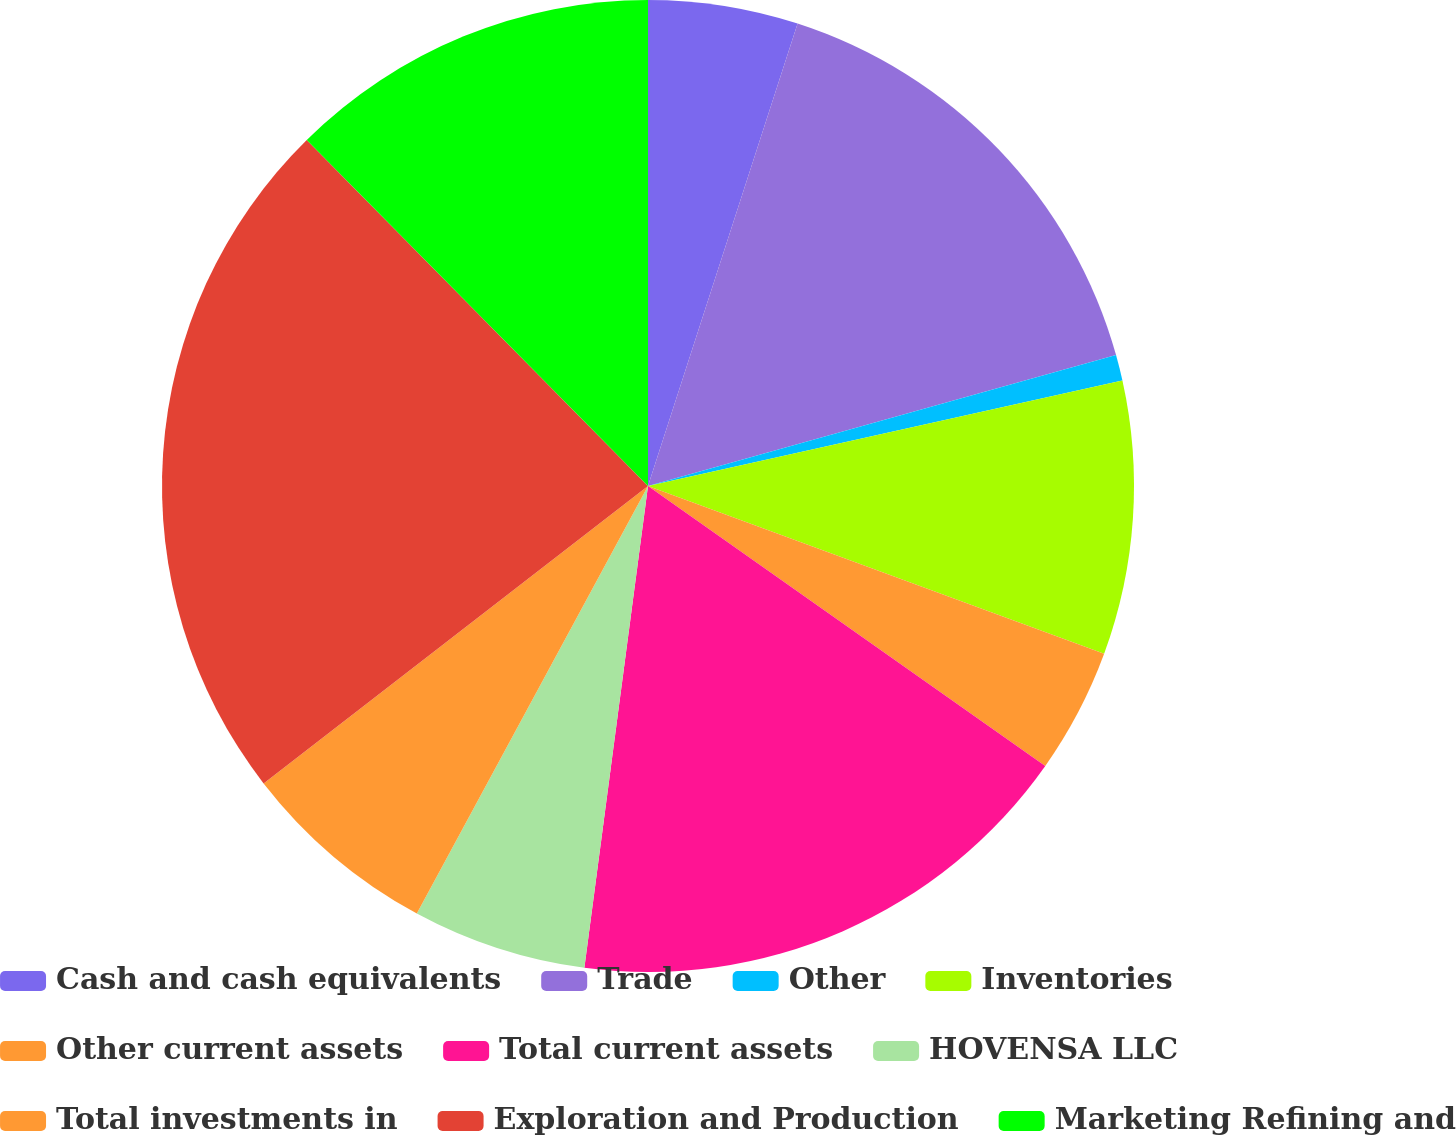<chart> <loc_0><loc_0><loc_500><loc_500><pie_chart><fcel>Cash and cash equivalents<fcel>Trade<fcel>Other<fcel>Inventories<fcel>Other current assets<fcel>Total current assets<fcel>HOVENSA LLC<fcel>Total investments in<fcel>Exploration and Production<fcel>Marketing Refining and<nl><fcel>4.98%<fcel>15.68%<fcel>0.86%<fcel>9.09%<fcel>4.16%<fcel>17.32%<fcel>5.8%<fcel>6.63%<fcel>23.09%<fcel>12.39%<nl></chart> 